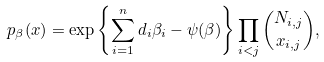Convert formula to latex. <formula><loc_0><loc_0><loc_500><loc_500>p _ { \beta } ( x ) = \exp \left \{ \sum _ { i = 1 } ^ { n } d _ { i } \beta _ { i } - \psi ( \beta ) \right \} \prod _ { i < j } { N _ { i , j } \choose x _ { i , j } } ,</formula> 